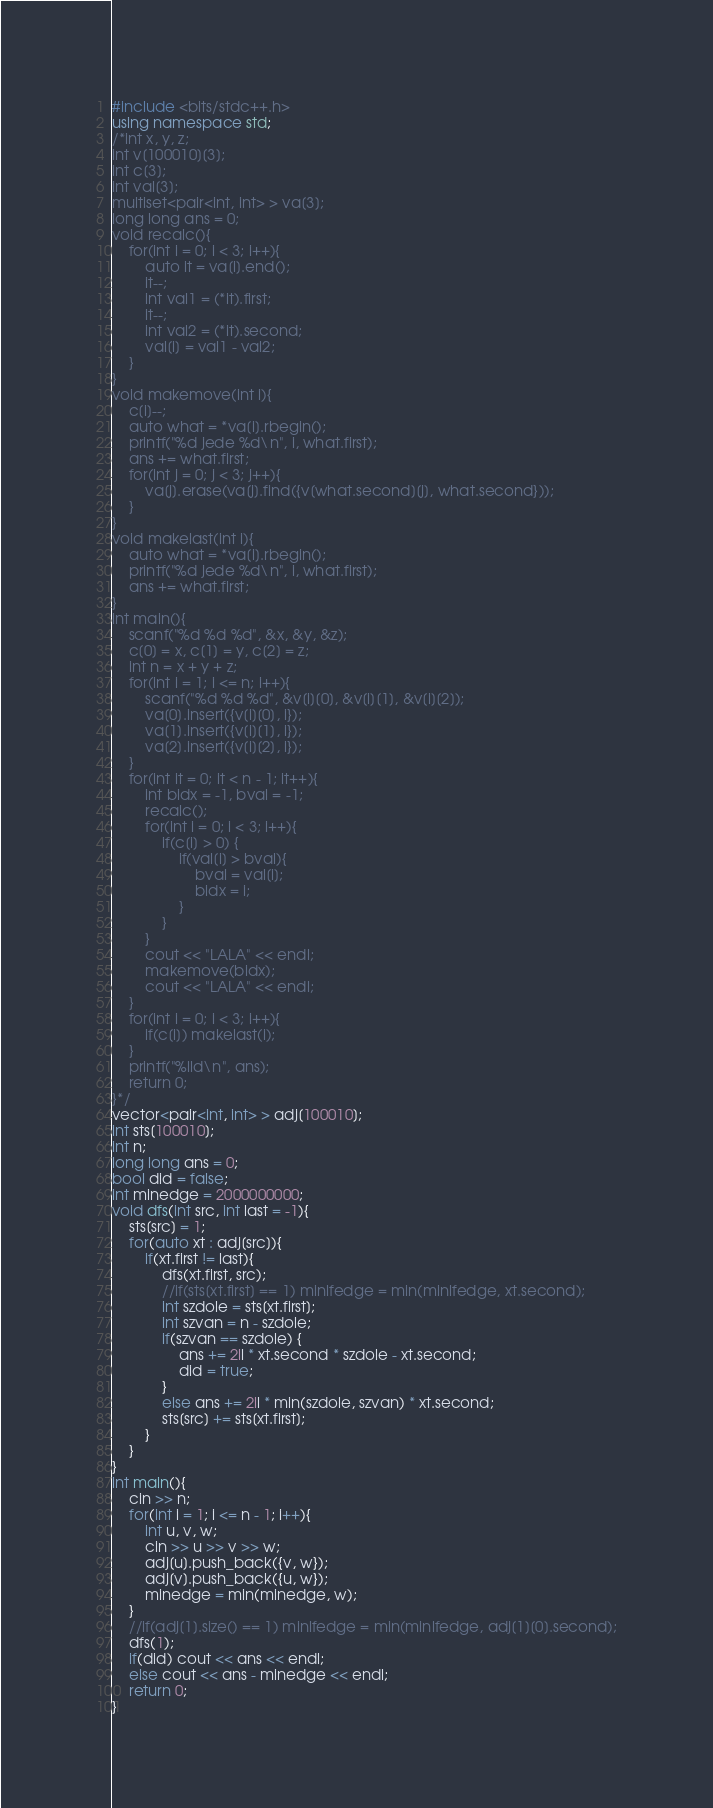Convert code to text. <code><loc_0><loc_0><loc_500><loc_500><_C++_>#include <bits/stdc++.h>
using namespace std;
/*int x, y, z;
int v[100010][3];
int c[3];
int val[3];
multiset<pair<int, int> > va[3];
long long ans = 0;
void recalc(){
	for(int i = 0; i < 3; i++){
		auto it = va[i].end();
		it--;
		int val1 = (*it).first;
		it--;
		int val2 = (*it).second;
		val[i] = val1 - val2;
	}
}
void makemove(int i){
	c[i]--;
	auto what = *va[i].rbegin();
	printf("%d jede %d\n", i, what.first);
	ans += what.first;
	for(int j = 0; j < 3; j++){
		va[j].erase(va[j].find({v[what.second][j], what.second}));
	}
}
void makelast(int i){
	auto what = *va[i].rbegin();
	printf("%d jede %d\n", i, what.first);
	ans += what.first;
}
int main(){
	scanf("%d %d %d", &x, &y, &z);
	c[0] = x, c[1] = y, c[2] = z;
	int n = x + y + z;
	for(int i = 1; i <= n; i++){
		scanf("%d %d %d", &v[i][0], &v[i][1], &v[i][2]);
		va[0].insert({v[i][0], i});
		va[1].insert({v[i][1], i});
		va[2].insert({v[i][2], i});
	}
	for(int it = 0; it < n - 1; it++){
		int bidx = -1, bval = -1;
		recalc();
		for(int i = 0; i < 3; i++){
			if(c[i] > 0) {
				if(val[i] > bval){
					bval = val[i];
					bidx = i;
				}
			}
		}
		cout << "LALA" << endl;
		makemove(bidx);
		cout << "LALA" << endl;
	}
	for(int i = 0; i < 3; i++){
		if(c[i]) makelast(i);
	}
	printf("%lld\n", ans);
	return 0;
}*/
vector<pair<int, int> > adj[100010];
int sts[100010];
int n;
long long ans = 0;
bool did = false;
int minedge = 2000000000;
void dfs(int src, int last = -1){
	sts[src] = 1;
	for(auto xt : adj[src]){
		if(xt.first != last){
			dfs(xt.first, src);
			//if(sts[xt.first] == 1) minlfedge = min(minlfedge, xt.second);
			int szdole = sts[xt.first];
			int szvan = n - szdole;
			if(szvan == szdole) {
				ans += 2ll * xt.second * szdole - xt.second;
				did = true;
			}
			else ans += 2ll * min(szdole, szvan) * xt.second;
			sts[src] += sts[xt.first];
		}
	}
}
int main(){
	cin >> n;
	for(int i = 1; i <= n - 1; i++){
		int u, v, w;
		cin >> u >> v >> w;
		adj[u].push_back({v, w});
		adj[v].push_back({u, w});
		minedge = min(minedge, w);
	}
	//if(adj[1].size() == 1) minlfedge = min(minlfedge, adj[1][0].second);
	dfs(1);
	if(did) cout << ans << endl;
	else cout << ans - minedge << endl;
	return 0;
}</code> 